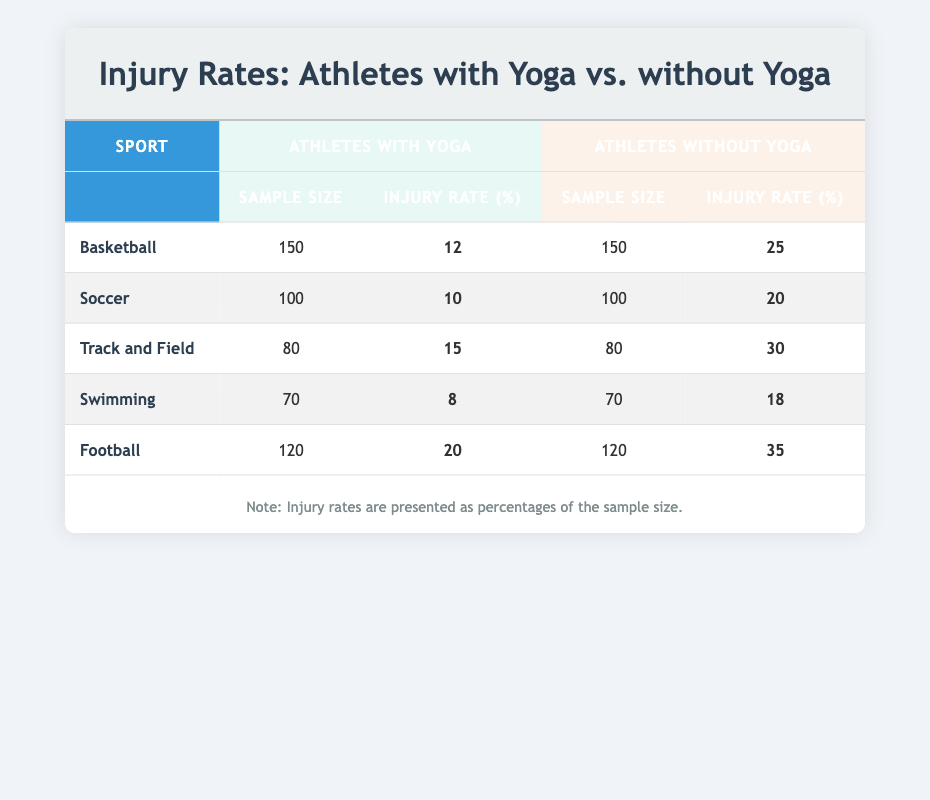What is the injury rate for athletes in Basketball who do not practice yoga? The injury rate for athletes without yoga in Basketball is provided in the table under the "Athletes without Yoga" column. It shows 25%.
Answer: 25% What is the sample size of athletes who practice yoga in the Soccer group? The sample size for athletes with yoga in Soccer is listed in the table under the "Sample Size" column for "Athletes with Yoga." It shows 100.
Answer: 100 Which sport has the lowest injury rate for athletes practicing yoga? By comparing the injury rates in the "Injury Rate (%)" column for "Athletes with Yoga," Swimming has the lowest rate at 8%.
Answer: 8% What is the average injury rate for athletes without yoga across all sports? The total injury rate for athletes without yoga can be calculated by summing the rates (25 + 20 + 30 + 18 + 35 = 128) and dividing by the number of sports (5). So, 128/5 = 25.6%.
Answer: 25.6% Do Track and Field athletes who practice yoga have a higher or lower injury rate than those who do not? The injury rate for Track and Field athletes with yoga is 15%, while without yoga it is 30%. Since 15% is less than 30%, they have a lower injury rate when practicing yoga.
Answer: Lower Which sport shows the greatest difference in injury rate between athletes with yoga and those without? By analyzing the differences in injury rates for each sport, the largest difference is found in Football, where the rate is 20% for athletes with yoga and 35% for those without, resulting in a difference of 15%.
Answer: Football Is it true that all sports listed have lower injury rates for athletes who practice yoga compared to those who do not? By examining the data in the table, all injury rates for athletes with yoga are indeed lower than those without yoga in every sport. Thus, the statement is true.
Answer: Yes Calculate the total sample size of athletes who practice yoga across all sports. To find the total sample size for athletes with yoga, add up the sample sizes for Basketball, Soccer, Track and Field, Swimming, and Football (150 + 100 + 80 + 70 + 120 = 620).
Answer: 620 